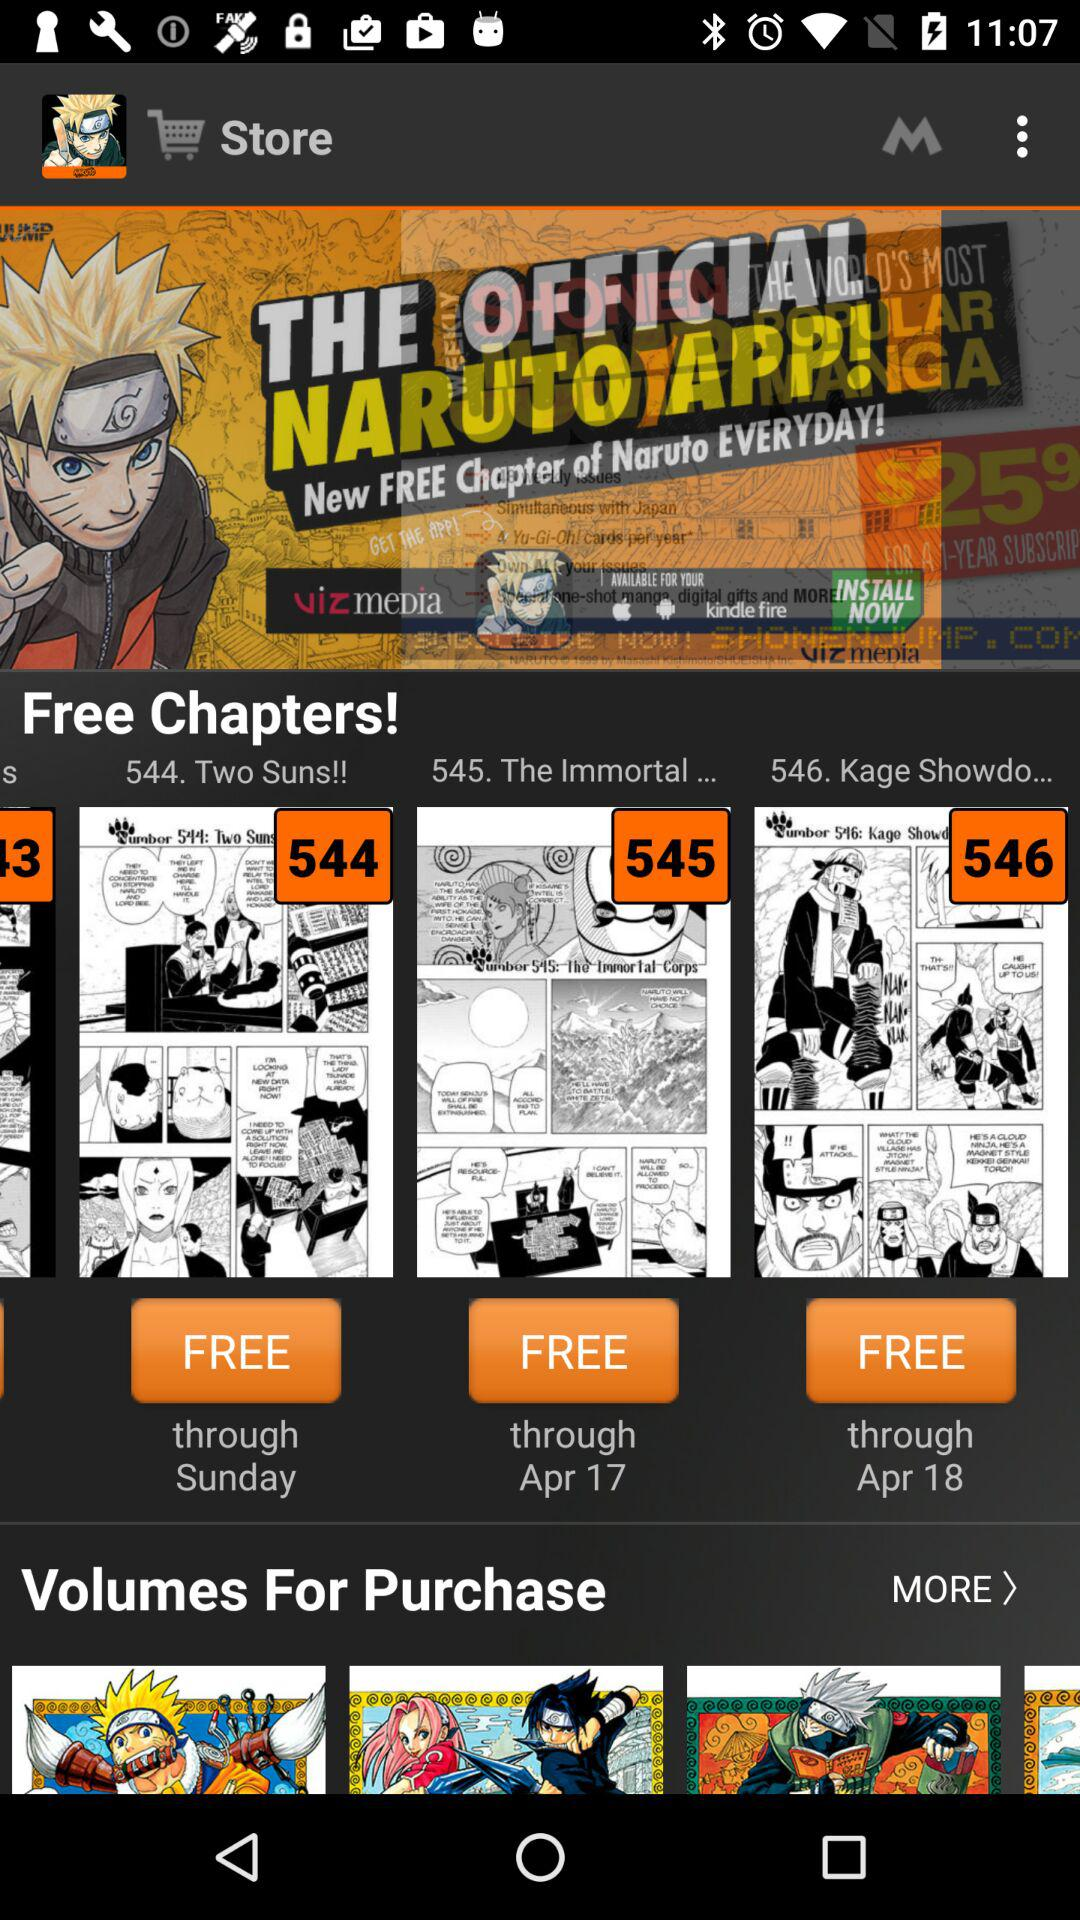Which chapter is the most recent?
Answer the question using a single word or phrase. 546 